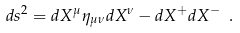Convert formula to latex. <formula><loc_0><loc_0><loc_500><loc_500>d s ^ { 2 } = d X ^ { \mu } \eta _ { \mu \nu } d X ^ { \nu } - d X ^ { + } d X ^ { - } \ .</formula> 